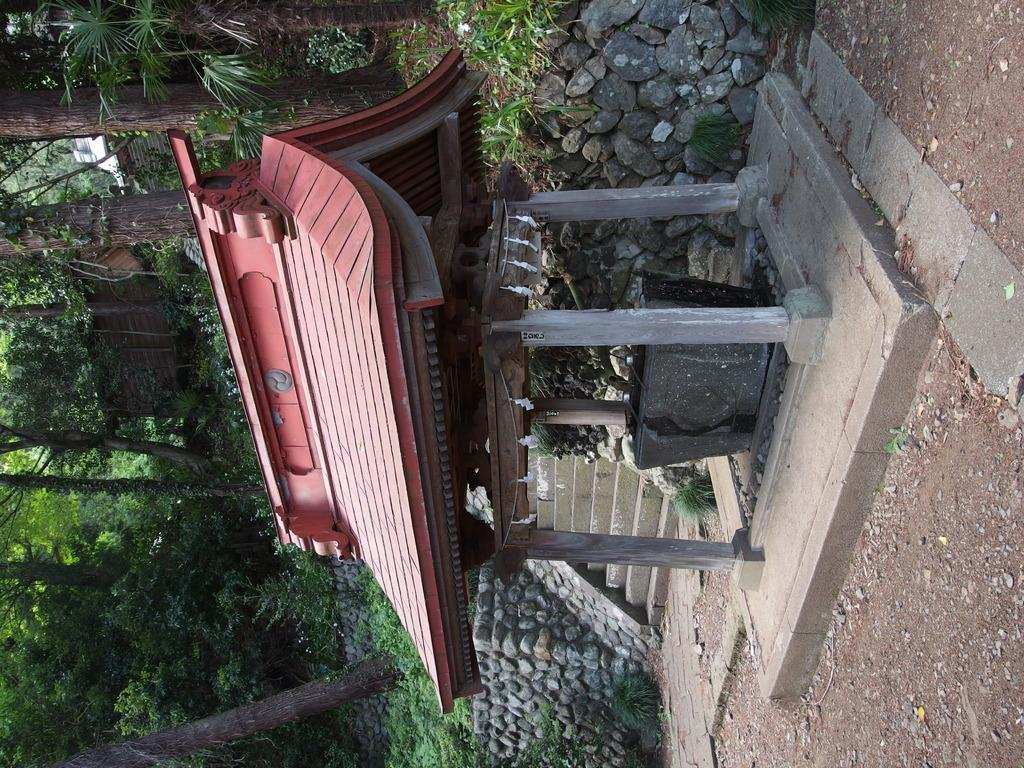What type of structure is in the foreground of the image? There is a red Chinese shed in the foreground of the image. Can you describe the shed's color? The shed is red. What can be seen in the background of the image? There is grass and trees in the background of the image. How many planes can be seen flying over the shed in the image? There are no planes visible in the image; it only features a red Chinese shed and the background with grass and trees. 